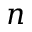Convert formula to latex. <formula><loc_0><loc_0><loc_500><loc_500>n</formula> 